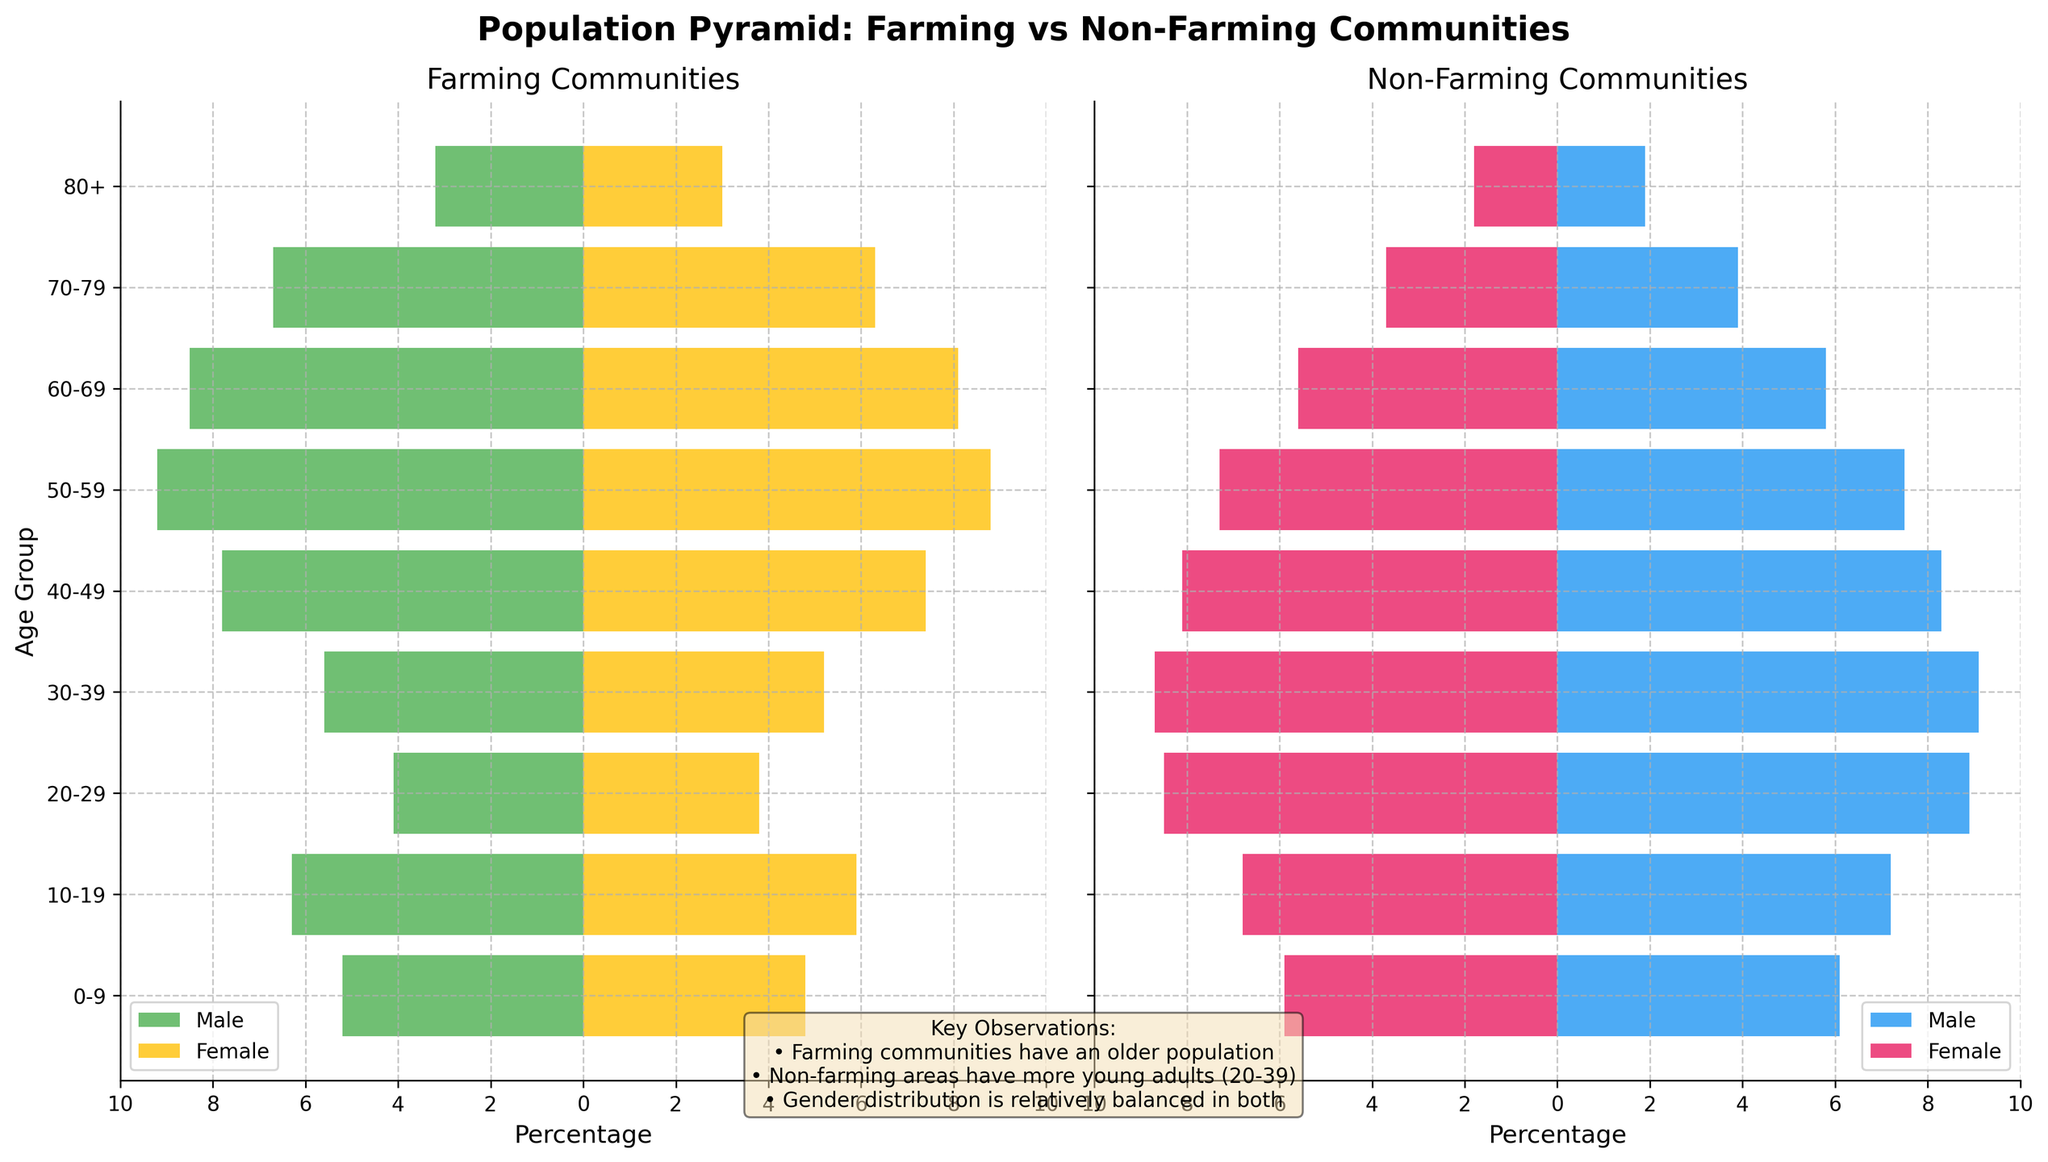what is the title of the figure? The title of the figure is usually placed at the top and is generally in a larger and bolder font. Here, we see "Population Pyramid: Farming vs Non-Farming Communities" right at the top of the plot.
Answer: Population Pyramid: Farming vs Non-Farming Communities What is the color used to represent females in farming communities? The color used for females in farming communities is represented in the plot legend. It shows that females are represented by the color yellow (#FFC107).
Answer: Yellow Which age group has the highest percentage of males in non-farming communities? By examining the blue bars in the non-farming communities section, the bar for the 30-39 age group is the longest, indicating it has the highest percentage of males.
Answer: 30-39 By how much is the percentage of females in the 60-69 age group higher in farming communities compared to non-farming communities? To find this, look at the lengths of the orange bars in the 60-69 age group for both communities. For farming communities, it is 8.1%, and for non-farming communities, it is 5.6%. The difference is 8.1% - 5.6% = 2.5%.
Answer: 2.5% What is the combined percentage of males in the 10-19 and 20-29 age groups in non-farming communities? Check the lengths of the blue bars for the 10-19 and 20-29 age groups in non-farming communities and sum them. The bars are 7.2% and 8.9% long, respectively. The combined percentage is 7.2% + 8.9% = 16.1%.
Answer: 16.1% Which community has a higher percentage of people aged 80+? Compare the bars for the 80+ age group in both plots. Farming communities have 3.2% (males) and 3.0% (females), while non-farming communities have 1.9% (males) and 1.8% (females). Farming communities have higher percentages in both genders.
Answer: Farming communities Is the gender distribution balanced in the 50-59 age group for farming communities? In the farming communities plot, look at the 50-59 age group's bars. For males, it's 9.2% and for females, it's 8.8%. Since 9.2% and 8.8% are very close, it can be considered relatively balanced.
Answer: Yes Which community has a younger population? Examine the age groups from 0-39. Non-farming communities have consistently higher percentages in the younger age groups (represented by longer bars in the younger age intervals). Thus, non-farming communities have a younger population.
Answer: Non-farming communities 